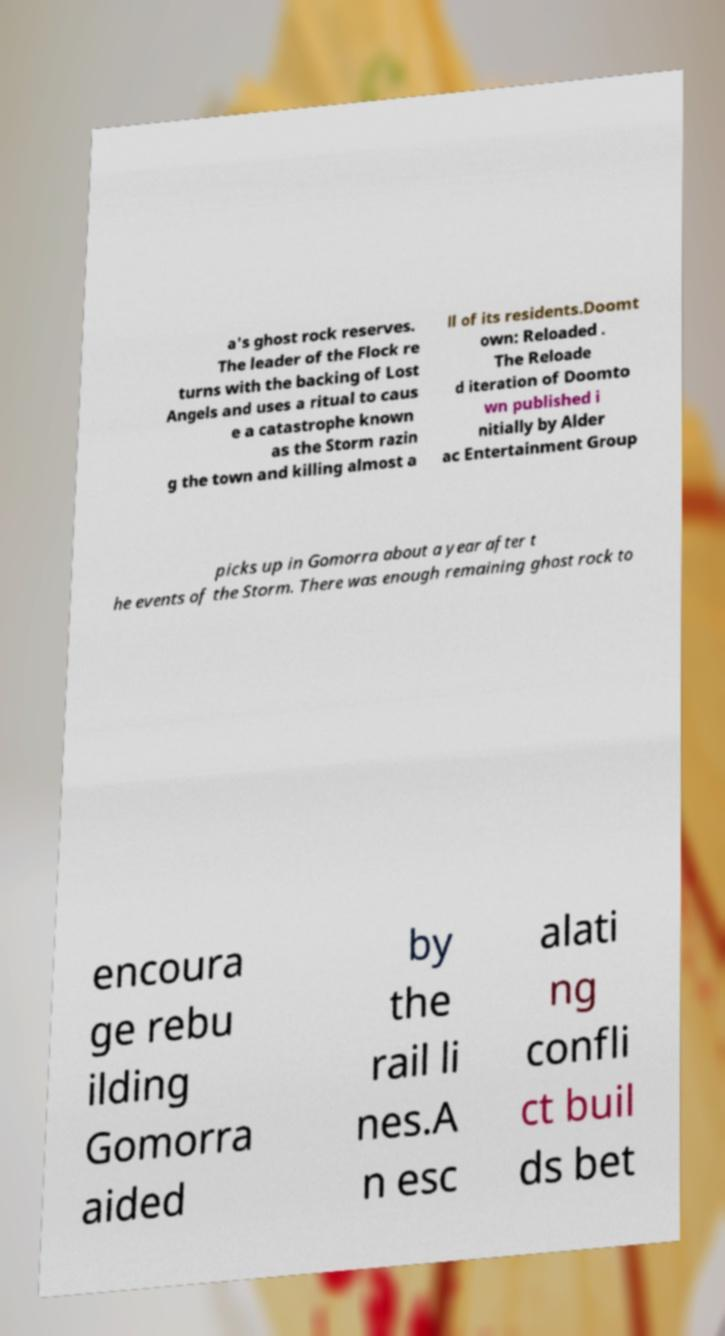Please read and relay the text visible in this image. What does it say? a's ghost rock reserves. The leader of the Flock re turns with the backing of Lost Angels and uses a ritual to caus e a catastrophe known as the Storm razin g the town and killing almost a ll of its residents.Doomt own: Reloaded . The Reloade d iteration of Doomto wn published i nitially by Alder ac Entertainment Group picks up in Gomorra about a year after t he events of the Storm. There was enough remaining ghost rock to encoura ge rebu ilding Gomorra aided by the rail li nes.A n esc alati ng confli ct buil ds bet 